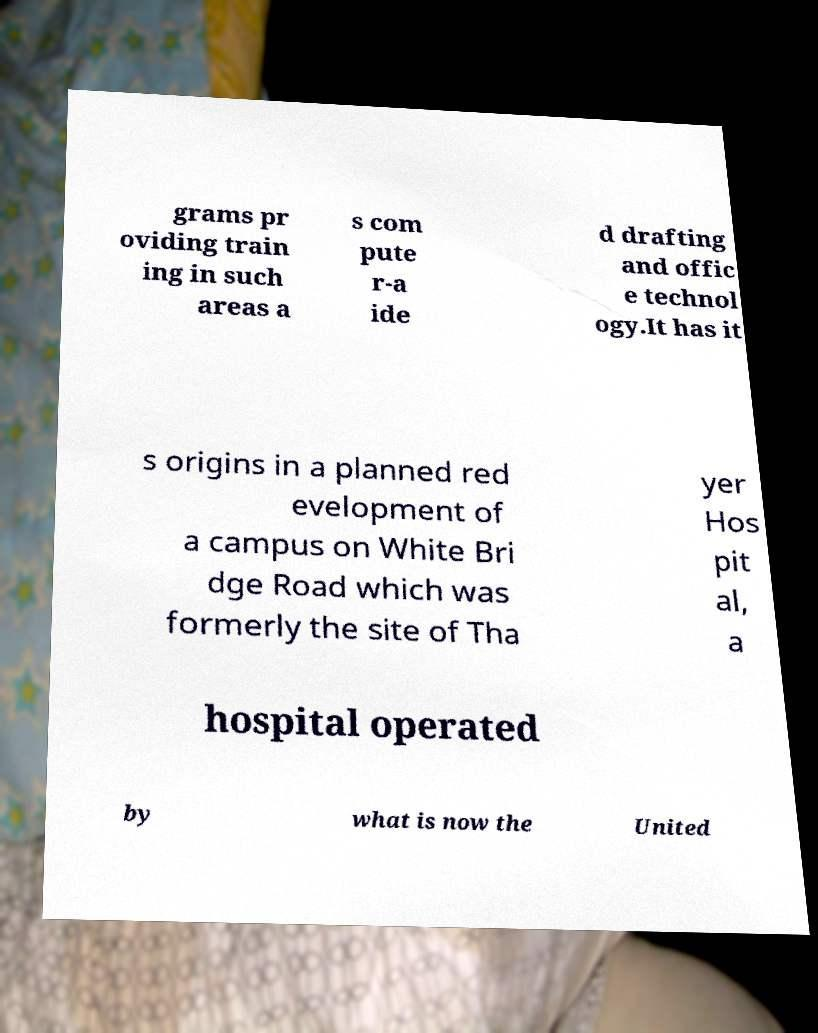Please identify and transcribe the text found in this image. grams pr oviding train ing in such areas a s com pute r-a ide d drafting and offic e technol ogy.It has it s origins in a planned red evelopment of a campus on White Bri dge Road which was formerly the site of Tha yer Hos pit al, a hospital operated by what is now the United 